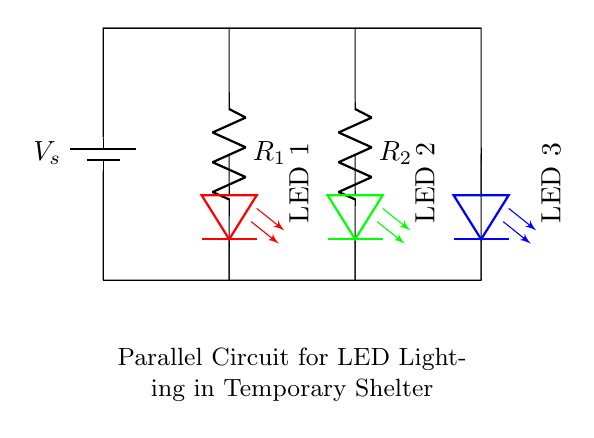What components are in the circuit? The circuit consists of a battery and three resistors along with three LED lights.
Answer: battery, resistors, LEDs What colors are the LEDs in the circuit? The circuit contains three LEDs: one red, one green, and one blue.
Answer: red, green, blue How many resistors are present in the circuit? There are two resistors connected in the circuit, each in parallel with the LEDs.
Answer: two What is the purpose of having multiple LEDs in a parallel circuit? The purpose is to allow each LED to operate independently so that if one fails, the others remain lit.
Answer: independent operation What is the total resistance of the circuit when resistors are connected in parallel? The total resistance in a parallel circuit decreases and can be calculated using the formula for parallel resistances, but to answer concisely: the total resistance is less than the smallest resistor value.
Answer: less than smallest resistor value 